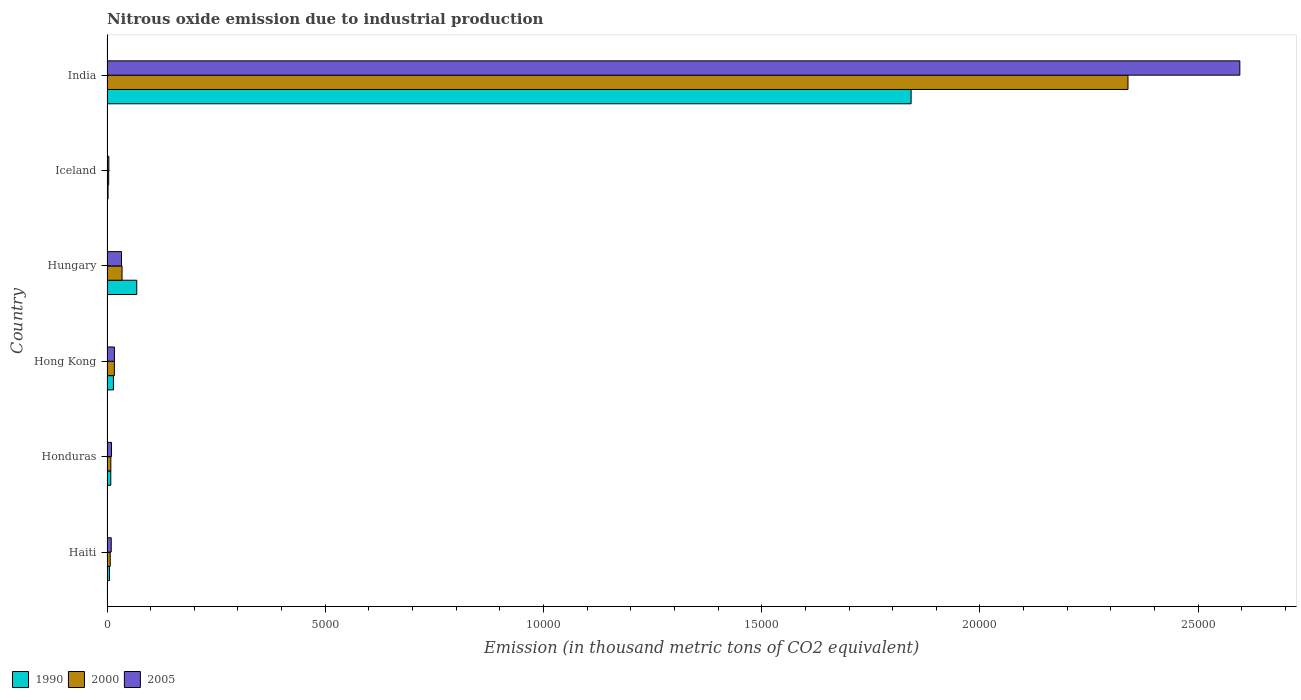How many different coloured bars are there?
Provide a short and direct response. 3. Are the number of bars per tick equal to the number of legend labels?
Make the answer very short. Yes. Are the number of bars on each tick of the Y-axis equal?
Make the answer very short. Yes. How many bars are there on the 5th tick from the top?
Your response must be concise. 3. How many bars are there on the 6th tick from the bottom?
Provide a succinct answer. 3. What is the label of the 4th group of bars from the top?
Your response must be concise. Hong Kong. In how many cases, is the number of bars for a given country not equal to the number of legend labels?
Your answer should be very brief. 0. What is the amount of nitrous oxide emitted in 2000 in India?
Keep it short and to the point. 2.34e+04. Across all countries, what is the maximum amount of nitrous oxide emitted in 2000?
Your answer should be compact. 2.34e+04. Across all countries, what is the minimum amount of nitrous oxide emitted in 2000?
Your response must be concise. 38.6. In which country was the amount of nitrous oxide emitted in 2000 minimum?
Provide a succinct answer. Iceland. What is the total amount of nitrous oxide emitted in 2005 in the graph?
Your answer should be compact. 2.67e+04. What is the difference between the amount of nitrous oxide emitted in 1990 in Honduras and that in India?
Offer a very short reply. -1.83e+04. What is the difference between the amount of nitrous oxide emitted in 2005 in Iceland and the amount of nitrous oxide emitted in 1990 in Hungary?
Offer a terse response. -639.6. What is the average amount of nitrous oxide emitted in 2005 per country?
Ensure brevity in your answer.  4449.87. What is the difference between the amount of nitrous oxide emitted in 2005 and amount of nitrous oxide emitted in 2000 in Hungary?
Offer a terse response. -11.9. In how many countries, is the amount of nitrous oxide emitted in 2005 greater than 3000 thousand metric tons?
Provide a succinct answer. 1. What is the ratio of the amount of nitrous oxide emitted in 2000 in Hungary to that in India?
Provide a short and direct response. 0.01. Is the difference between the amount of nitrous oxide emitted in 2005 in Haiti and Hong Kong greater than the difference between the amount of nitrous oxide emitted in 2000 in Haiti and Hong Kong?
Provide a succinct answer. Yes. What is the difference between the highest and the second highest amount of nitrous oxide emitted in 2005?
Your answer should be compact. 2.56e+04. What is the difference between the highest and the lowest amount of nitrous oxide emitted in 2005?
Offer a terse response. 2.59e+04. Is the sum of the amount of nitrous oxide emitted in 2000 in Haiti and Hungary greater than the maximum amount of nitrous oxide emitted in 1990 across all countries?
Make the answer very short. No. What does the 1st bar from the bottom in Haiti represents?
Give a very brief answer. 1990. How many countries are there in the graph?
Offer a terse response. 6. What is the difference between two consecutive major ticks on the X-axis?
Provide a short and direct response. 5000. Does the graph contain any zero values?
Give a very brief answer. No. Does the graph contain grids?
Give a very brief answer. No. Where does the legend appear in the graph?
Offer a terse response. Bottom left. How many legend labels are there?
Your answer should be compact. 3. How are the legend labels stacked?
Your answer should be very brief. Horizontal. What is the title of the graph?
Your answer should be very brief. Nitrous oxide emission due to industrial production. Does "2004" appear as one of the legend labels in the graph?
Provide a succinct answer. No. What is the label or title of the X-axis?
Provide a short and direct response. Emission (in thousand metric tons of CO2 equivalent). What is the label or title of the Y-axis?
Provide a short and direct response. Country. What is the Emission (in thousand metric tons of CO2 equivalent) in 1990 in Haiti?
Your response must be concise. 56.6. What is the Emission (in thousand metric tons of CO2 equivalent) in 2000 in Haiti?
Offer a terse response. 73.8. What is the Emission (in thousand metric tons of CO2 equivalent) of 2005 in Haiti?
Keep it short and to the point. 97. What is the Emission (in thousand metric tons of CO2 equivalent) of 1990 in Honduras?
Offer a very short reply. 86.6. What is the Emission (in thousand metric tons of CO2 equivalent) of 2000 in Honduras?
Offer a very short reply. 87.5. What is the Emission (in thousand metric tons of CO2 equivalent) in 2005 in Honduras?
Your answer should be compact. 103.3. What is the Emission (in thousand metric tons of CO2 equivalent) of 1990 in Hong Kong?
Your answer should be compact. 147.8. What is the Emission (in thousand metric tons of CO2 equivalent) in 2000 in Hong Kong?
Provide a succinct answer. 168.9. What is the Emission (in thousand metric tons of CO2 equivalent) of 2005 in Hong Kong?
Give a very brief answer. 169.8. What is the Emission (in thousand metric tons of CO2 equivalent) of 1990 in Hungary?
Provide a succinct answer. 681.7. What is the Emission (in thousand metric tons of CO2 equivalent) in 2000 in Hungary?
Provide a succinct answer. 344.5. What is the Emission (in thousand metric tons of CO2 equivalent) in 2005 in Hungary?
Your answer should be compact. 332.6. What is the Emission (in thousand metric tons of CO2 equivalent) of 1990 in Iceland?
Give a very brief answer. 24.6. What is the Emission (in thousand metric tons of CO2 equivalent) in 2000 in Iceland?
Offer a terse response. 38.6. What is the Emission (in thousand metric tons of CO2 equivalent) of 2005 in Iceland?
Ensure brevity in your answer.  42.1. What is the Emission (in thousand metric tons of CO2 equivalent) of 1990 in India?
Make the answer very short. 1.84e+04. What is the Emission (in thousand metric tons of CO2 equivalent) of 2000 in India?
Provide a succinct answer. 2.34e+04. What is the Emission (in thousand metric tons of CO2 equivalent) of 2005 in India?
Your response must be concise. 2.60e+04. Across all countries, what is the maximum Emission (in thousand metric tons of CO2 equivalent) of 1990?
Give a very brief answer. 1.84e+04. Across all countries, what is the maximum Emission (in thousand metric tons of CO2 equivalent) of 2000?
Provide a succinct answer. 2.34e+04. Across all countries, what is the maximum Emission (in thousand metric tons of CO2 equivalent) in 2005?
Give a very brief answer. 2.60e+04. Across all countries, what is the minimum Emission (in thousand metric tons of CO2 equivalent) in 1990?
Your answer should be very brief. 24.6. Across all countries, what is the minimum Emission (in thousand metric tons of CO2 equivalent) in 2000?
Your answer should be compact. 38.6. Across all countries, what is the minimum Emission (in thousand metric tons of CO2 equivalent) in 2005?
Offer a very short reply. 42.1. What is the total Emission (in thousand metric tons of CO2 equivalent) of 1990 in the graph?
Your answer should be compact. 1.94e+04. What is the total Emission (in thousand metric tons of CO2 equivalent) in 2000 in the graph?
Give a very brief answer. 2.41e+04. What is the total Emission (in thousand metric tons of CO2 equivalent) in 2005 in the graph?
Provide a short and direct response. 2.67e+04. What is the difference between the Emission (in thousand metric tons of CO2 equivalent) of 2000 in Haiti and that in Honduras?
Your answer should be compact. -13.7. What is the difference between the Emission (in thousand metric tons of CO2 equivalent) of 2005 in Haiti and that in Honduras?
Your answer should be very brief. -6.3. What is the difference between the Emission (in thousand metric tons of CO2 equivalent) in 1990 in Haiti and that in Hong Kong?
Keep it short and to the point. -91.2. What is the difference between the Emission (in thousand metric tons of CO2 equivalent) in 2000 in Haiti and that in Hong Kong?
Your answer should be very brief. -95.1. What is the difference between the Emission (in thousand metric tons of CO2 equivalent) in 2005 in Haiti and that in Hong Kong?
Your response must be concise. -72.8. What is the difference between the Emission (in thousand metric tons of CO2 equivalent) of 1990 in Haiti and that in Hungary?
Your answer should be very brief. -625.1. What is the difference between the Emission (in thousand metric tons of CO2 equivalent) in 2000 in Haiti and that in Hungary?
Ensure brevity in your answer.  -270.7. What is the difference between the Emission (in thousand metric tons of CO2 equivalent) of 2005 in Haiti and that in Hungary?
Provide a short and direct response. -235.6. What is the difference between the Emission (in thousand metric tons of CO2 equivalent) in 2000 in Haiti and that in Iceland?
Provide a succinct answer. 35.2. What is the difference between the Emission (in thousand metric tons of CO2 equivalent) of 2005 in Haiti and that in Iceland?
Ensure brevity in your answer.  54.9. What is the difference between the Emission (in thousand metric tons of CO2 equivalent) in 1990 in Haiti and that in India?
Your response must be concise. -1.84e+04. What is the difference between the Emission (in thousand metric tons of CO2 equivalent) of 2000 in Haiti and that in India?
Ensure brevity in your answer.  -2.33e+04. What is the difference between the Emission (in thousand metric tons of CO2 equivalent) of 2005 in Haiti and that in India?
Provide a succinct answer. -2.59e+04. What is the difference between the Emission (in thousand metric tons of CO2 equivalent) of 1990 in Honduras and that in Hong Kong?
Ensure brevity in your answer.  -61.2. What is the difference between the Emission (in thousand metric tons of CO2 equivalent) in 2000 in Honduras and that in Hong Kong?
Offer a very short reply. -81.4. What is the difference between the Emission (in thousand metric tons of CO2 equivalent) of 2005 in Honduras and that in Hong Kong?
Offer a very short reply. -66.5. What is the difference between the Emission (in thousand metric tons of CO2 equivalent) of 1990 in Honduras and that in Hungary?
Make the answer very short. -595.1. What is the difference between the Emission (in thousand metric tons of CO2 equivalent) of 2000 in Honduras and that in Hungary?
Provide a succinct answer. -257. What is the difference between the Emission (in thousand metric tons of CO2 equivalent) in 2005 in Honduras and that in Hungary?
Keep it short and to the point. -229.3. What is the difference between the Emission (in thousand metric tons of CO2 equivalent) of 1990 in Honduras and that in Iceland?
Your answer should be compact. 62. What is the difference between the Emission (in thousand metric tons of CO2 equivalent) of 2000 in Honduras and that in Iceland?
Offer a terse response. 48.9. What is the difference between the Emission (in thousand metric tons of CO2 equivalent) in 2005 in Honduras and that in Iceland?
Keep it short and to the point. 61.2. What is the difference between the Emission (in thousand metric tons of CO2 equivalent) of 1990 in Honduras and that in India?
Make the answer very short. -1.83e+04. What is the difference between the Emission (in thousand metric tons of CO2 equivalent) of 2000 in Honduras and that in India?
Ensure brevity in your answer.  -2.33e+04. What is the difference between the Emission (in thousand metric tons of CO2 equivalent) in 2005 in Honduras and that in India?
Your answer should be very brief. -2.59e+04. What is the difference between the Emission (in thousand metric tons of CO2 equivalent) of 1990 in Hong Kong and that in Hungary?
Your answer should be very brief. -533.9. What is the difference between the Emission (in thousand metric tons of CO2 equivalent) in 2000 in Hong Kong and that in Hungary?
Give a very brief answer. -175.6. What is the difference between the Emission (in thousand metric tons of CO2 equivalent) of 2005 in Hong Kong and that in Hungary?
Your answer should be very brief. -162.8. What is the difference between the Emission (in thousand metric tons of CO2 equivalent) in 1990 in Hong Kong and that in Iceland?
Provide a short and direct response. 123.2. What is the difference between the Emission (in thousand metric tons of CO2 equivalent) of 2000 in Hong Kong and that in Iceland?
Provide a short and direct response. 130.3. What is the difference between the Emission (in thousand metric tons of CO2 equivalent) of 2005 in Hong Kong and that in Iceland?
Ensure brevity in your answer.  127.7. What is the difference between the Emission (in thousand metric tons of CO2 equivalent) of 1990 in Hong Kong and that in India?
Provide a succinct answer. -1.83e+04. What is the difference between the Emission (in thousand metric tons of CO2 equivalent) of 2000 in Hong Kong and that in India?
Your answer should be very brief. -2.32e+04. What is the difference between the Emission (in thousand metric tons of CO2 equivalent) in 2005 in Hong Kong and that in India?
Provide a short and direct response. -2.58e+04. What is the difference between the Emission (in thousand metric tons of CO2 equivalent) in 1990 in Hungary and that in Iceland?
Give a very brief answer. 657.1. What is the difference between the Emission (in thousand metric tons of CO2 equivalent) of 2000 in Hungary and that in Iceland?
Make the answer very short. 305.9. What is the difference between the Emission (in thousand metric tons of CO2 equivalent) in 2005 in Hungary and that in Iceland?
Your answer should be very brief. 290.5. What is the difference between the Emission (in thousand metric tons of CO2 equivalent) of 1990 in Hungary and that in India?
Offer a very short reply. -1.77e+04. What is the difference between the Emission (in thousand metric tons of CO2 equivalent) in 2000 in Hungary and that in India?
Provide a short and direct response. -2.30e+04. What is the difference between the Emission (in thousand metric tons of CO2 equivalent) in 2005 in Hungary and that in India?
Give a very brief answer. -2.56e+04. What is the difference between the Emission (in thousand metric tons of CO2 equivalent) of 1990 in Iceland and that in India?
Give a very brief answer. -1.84e+04. What is the difference between the Emission (in thousand metric tons of CO2 equivalent) of 2000 in Iceland and that in India?
Your response must be concise. -2.34e+04. What is the difference between the Emission (in thousand metric tons of CO2 equivalent) in 2005 in Iceland and that in India?
Ensure brevity in your answer.  -2.59e+04. What is the difference between the Emission (in thousand metric tons of CO2 equivalent) in 1990 in Haiti and the Emission (in thousand metric tons of CO2 equivalent) in 2000 in Honduras?
Your answer should be very brief. -30.9. What is the difference between the Emission (in thousand metric tons of CO2 equivalent) in 1990 in Haiti and the Emission (in thousand metric tons of CO2 equivalent) in 2005 in Honduras?
Make the answer very short. -46.7. What is the difference between the Emission (in thousand metric tons of CO2 equivalent) of 2000 in Haiti and the Emission (in thousand metric tons of CO2 equivalent) of 2005 in Honduras?
Your answer should be very brief. -29.5. What is the difference between the Emission (in thousand metric tons of CO2 equivalent) in 1990 in Haiti and the Emission (in thousand metric tons of CO2 equivalent) in 2000 in Hong Kong?
Keep it short and to the point. -112.3. What is the difference between the Emission (in thousand metric tons of CO2 equivalent) of 1990 in Haiti and the Emission (in thousand metric tons of CO2 equivalent) of 2005 in Hong Kong?
Make the answer very short. -113.2. What is the difference between the Emission (in thousand metric tons of CO2 equivalent) of 2000 in Haiti and the Emission (in thousand metric tons of CO2 equivalent) of 2005 in Hong Kong?
Keep it short and to the point. -96. What is the difference between the Emission (in thousand metric tons of CO2 equivalent) of 1990 in Haiti and the Emission (in thousand metric tons of CO2 equivalent) of 2000 in Hungary?
Provide a short and direct response. -287.9. What is the difference between the Emission (in thousand metric tons of CO2 equivalent) in 1990 in Haiti and the Emission (in thousand metric tons of CO2 equivalent) in 2005 in Hungary?
Make the answer very short. -276. What is the difference between the Emission (in thousand metric tons of CO2 equivalent) in 2000 in Haiti and the Emission (in thousand metric tons of CO2 equivalent) in 2005 in Hungary?
Provide a succinct answer. -258.8. What is the difference between the Emission (in thousand metric tons of CO2 equivalent) in 2000 in Haiti and the Emission (in thousand metric tons of CO2 equivalent) in 2005 in Iceland?
Your response must be concise. 31.7. What is the difference between the Emission (in thousand metric tons of CO2 equivalent) of 1990 in Haiti and the Emission (in thousand metric tons of CO2 equivalent) of 2000 in India?
Provide a short and direct response. -2.33e+04. What is the difference between the Emission (in thousand metric tons of CO2 equivalent) in 1990 in Haiti and the Emission (in thousand metric tons of CO2 equivalent) in 2005 in India?
Offer a terse response. -2.59e+04. What is the difference between the Emission (in thousand metric tons of CO2 equivalent) in 2000 in Haiti and the Emission (in thousand metric tons of CO2 equivalent) in 2005 in India?
Your response must be concise. -2.59e+04. What is the difference between the Emission (in thousand metric tons of CO2 equivalent) of 1990 in Honduras and the Emission (in thousand metric tons of CO2 equivalent) of 2000 in Hong Kong?
Keep it short and to the point. -82.3. What is the difference between the Emission (in thousand metric tons of CO2 equivalent) in 1990 in Honduras and the Emission (in thousand metric tons of CO2 equivalent) in 2005 in Hong Kong?
Make the answer very short. -83.2. What is the difference between the Emission (in thousand metric tons of CO2 equivalent) in 2000 in Honduras and the Emission (in thousand metric tons of CO2 equivalent) in 2005 in Hong Kong?
Your response must be concise. -82.3. What is the difference between the Emission (in thousand metric tons of CO2 equivalent) of 1990 in Honduras and the Emission (in thousand metric tons of CO2 equivalent) of 2000 in Hungary?
Provide a short and direct response. -257.9. What is the difference between the Emission (in thousand metric tons of CO2 equivalent) of 1990 in Honduras and the Emission (in thousand metric tons of CO2 equivalent) of 2005 in Hungary?
Provide a short and direct response. -246. What is the difference between the Emission (in thousand metric tons of CO2 equivalent) in 2000 in Honduras and the Emission (in thousand metric tons of CO2 equivalent) in 2005 in Hungary?
Provide a succinct answer. -245.1. What is the difference between the Emission (in thousand metric tons of CO2 equivalent) of 1990 in Honduras and the Emission (in thousand metric tons of CO2 equivalent) of 2000 in Iceland?
Provide a short and direct response. 48. What is the difference between the Emission (in thousand metric tons of CO2 equivalent) of 1990 in Honduras and the Emission (in thousand metric tons of CO2 equivalent) of 2005 in Iceland?
Provide a short and direct response. 44.5. What is the difference between the Emission (in thousand metric tons of CO2 equivalent) of 2000 in Honduras and the Emission (in thousand metric tons of CO2 equivalent) of 2005 in Iceland?
Give a very brief answer. 45.4. What is the difference between the Emission (in thousand metric tons of CO2 equivalent) of 1990 in Honduras and the Emission (in thousand metric tons of CO2 equivalent) of 2000 in India?
Offer a very short reply. -2.33e+04. What is the difference between the Emission (in thousand metric tons of CO2 equivalent) of 1990 in Honduras and the Emission (in thousand metric tons of CO2 equivalent) of 2005 in India?
Provide a short and direct response. -2.59e+04. What is the difference between the Emission (in thousand metric tons of CO2 equivalent) of 2000 in Honduras and the Emission (in thousand metric tons of CO2 equivalent) of 2005 in India?
Your answer should be very brief. -2.59e+04. What is the difference between the Emission (in thousand metric tons of CO2 equivalent) in 1990 in Hong Kong and the Emission (in thousand metric tons of CO2 equivalent) in 2000 in Hungary?
Offer a very short reply. -196.7. What is the difference between the Emission (in thousand metric tons of CO2 equivalent) in 1990 in Hong Kong and the Emission (in thousand metric tons of CO2 equivalent) in 2005 in Hungary?
Your answer should be very brief. -184.8. What is the difference between the Emission (in thousand metric tons of CO2 equivalent) in 2000 in Hong Kong and the Emission (in thousand metric tons of CO2 equivalent) in 2005 in Hungary?
Keep it short and to the point. -163.7. What is the difference between the Emission (in thousand metric tons of CO2 equivalent) of 1990 in Hong Kong and the Emission (in thousand metric tons of CO2 equivalent) of 2000 in Iceland?
Provide a short and direct response. 109.2. What is the difference between the Emission (in thousand metric tons of CO2 equivalent) of 1990 in Hong Kong and the Emission (in thousand metric tons of CO2 equivalent) of 2005 in Iceland?
Your answer should be compact. 105.7. What is the difference between the Emission (in thousand metric tons of CO2 equivalent) in 2000 in Hong Kong and the Emission (in thousand metric tons of CO2 equivalent) in 2005 in Iceland?
Keep it short and to the point. 126.8. What is the difference between the Emission (in thousand metric tons of CO2 equivalent) in 1990 in Hong Kong and the Emission (in thousand metric tons of CO2 equivalent) in 2000 in India?
Your answer should be very brief. -2.32e+04. What is the difference between the Emission (in thousand metric tons of CO2 equivalent) of 1990 in Hong Kong and the Emission (in thousand metric tons of CO2 equivalent) of 2005 in India?
Your response must be concise. -2.58e+04. What is the difference between the Emission (in thousand metric tons of CO2 equivalent) of 2000 in Hong Kong and the Emission (in thousand metric tons of CO2 equivalent) of 2005 in India?
Your answer should be very brief. -2.58e+04. What is the difference between the Emission (in thousand metric tons of CO2 equivalent) in 1990 in Hungary and the Emission (in thousand metric tons of CO2 equivalent) in 2000 in Iceland?
Your answer should be compact. 643.1. What is the difference between the Emission (in thousand metric tons of CO2 equivalent) of 1990 in Hungary and the Emission (in thousand metric tons of CO2 equivalent) of 2005 in Iceland?
Your answer should be compact. 639.6. What is the difference between the Emission (in thousand metric tons of CO2 equivalent) of 2000 in Hungary and the Emission (in thousand metric tons of CO2 equivalent) of 2005 in Iceland?
Give a very brief answer. 302.4. What is the difference between the Emission (in thousand metric tons of CO2 equivalent) in 1990 in Hungary and the Emission (in thousand metric tons of CO2 equivalent) in 2000 in India?
Offer a very short reply. -2.27e+04. What is the difference between the Emission (in thousand metric tons of CO2 equivalent) in 1990 in Hungary and the Emission (in thousand metric tons of CO2 equivalent) in 2005 in India?
Provide a short and direct response. -2.53e+04. What is the difference between the Emission (in thousand metric tons of CO2 equivalent) in 2000 in Hungary and the Emission (in thousand metric tons of CO2 equivalent) in 2005 in India?
Provide a short and direct response. -2.56e+04. What is the difference between the Emission (in thousand metric tons of CO2 equivalent) in 1990 in Iceland and the Emission (in thousand metric tons of CO2 equivalent) in 2000 in India?
Your answer should be compact. -2.34e+04. What is the difference between the Emission (in thousand metric tons of CO2 equivalent) of 1990 in Iceland and the Emission (in thousand metric tons of CO2 equivalent) of 2005 in India?
Make the answer very short. -2.59e+04. What is the difference between the Emission (in thousand metric tons of CO2 equivalent) in 2000 in Iceland and the Emission (in thousand metric tons of CO2 equivalent) in 2005 in India?
Offer a very short reply. -2.59e+04. What is the average Emission (in thousand metric tons of CO2 equivalent) in 1990 per country?
Provide a short and direct response. 3236.68. What is the average Emission (in thousand metric tons of CO2 equivalent) of 2000 per country?
Offer a terse response. 4017.43. What is the average Emission (in thousand metric tons of CO2 equivalent) of 2005 per country?
Keep it short and to the point. 4449.87. What is the difference between the Emission (in thousand metric tons of CO2 equivalent) of 1990 and Emission (in thousand metric tons of CO2 equivalent) of 2000 in Haiti?
Give a very brief answer. -17.2. What is the difference between the Emission (in thousand metric tons of CO2 equivalent) of 1990 and Emission (in thousand metric tons of CO2 equivalent) of 2005 in Haiti?
Your response must be concise. -40.4. What is the difference between the Emission (in thousand metric tons of CO2 equivalent) of 2000 and Emission (in thousand metric tons of CO2 equivalent) of 2005 in Haiti?
Your answer should be very brief. -23.2. What is the difference between the Emission (in thousand metric tons of CO2 equivalent) of 1990 and Emission (in thousand metric tons of CO2 equivalent) of 2000 in Honduras?
Make the answer very short. -0.9. What is the difference between the Emission (in thousand metric tons of CO2 equivalent) in 1990 and Emission (in thousand metric tons of CO2 equivalent) in 2005 in Honduras?
Offer a terse response. -16.7. What is the difference between the Emission (in thousand metric tons of CO2 equivalent) in 2000 and Emission (in thousand metric tons of CO2 equivalent) in 2005 in Honduras?
Provide a succinct answer. -15.8. What is the difference between the Emission (in thousand metric tons of CO2 equivalent) of 1990 and Emission (in thousand metric tons of CO2 equivalent) of 2000 in Hong Kong?
Your answer should be very brief. -21.1. What is the difference between the Emission (in thousand metric tons of CO2 equivalent) of 1990 and Emission (in thousand metric tons of CO2 equivalent) of 2000 in Hungary?
Offer a terse response. 337.2. What is the difference between the Emission (in thousand metric tons of CO2 equivalent) of 1990 and Emission (in thousand metric tons of CO2 equivalent) of 2005 in Hungary?
Offer a terse response. 349.1. What is the difference between the Emission (in thousand metric tons of CO2 equivalent) of 2000 and Emission (in thousand metric tons of CO2 equivalent) of 2005 in Hungary?
Ensure brevity in your answer.  11.9. What is the difference between the Emission (in thousand metric tons of CO2 equivalent) of 1990 and Emission (in thousand metric tons of CO2 equivalent) of 2005 in Iceland?
Keep it short and to the point. -17.5. What is the difference between the Emission (in thousand metric tons of CO2 equivalent) of 1990 and Emission (in thousand metric tons of CO2 equivalent) of 2000 in India?
Offer a terse response. -4968.5. What is the difference between the Emission (in thousand metric tons of CO2 equivalent) of 1990 and Emission (in thousand metric tons of CO2 equivalent) of 2005 in India?
Provide a short and direct response. -7531.6. What is the difference between the Emission (in thousand metric tons of CO2 equivalent) in 2000 and Emission (in thousand metric tons of CO2 equivalent) in 2005 in India?
Keep it short and to the point. -2563.1. What is the ratio of the Emission (in thousand metric tons of CO2 equivalent) in 1990 in Haiti to that in Honduras?
Offer a terse response. 0.65. What is the ratio of the Emission (in thousand metric tons of CO2 equivalent) in 2000 in Haiti to that in Honduras?
Offer a very short reply. 0.84. What is the ratio of the Emission (in thousand metric tons of CO2 equivalent) of 2005 in Haiti to that in Honduras?
Provide a succinct answer. 0.94. What is the ratio of the Emission (in thousand metric tons of CO2 equivalent) in 1990 in Haiti to that in Hong Kong?
Offer a terse response. 0.38. What is the ratio of the Emission (in thousand metric tons of CO2 equivalent) of 2000 in Haiti to that in Hong Kong?
Your response must be concise. 0.44. What is the ratio of the Emission (in thousand metric tons of CO2 equivalent) in 2005 in Haiti to that in Hong Kong?
Keep it short and to the point. 0.57. What is the ratio of the Emission (in thousand metric tons of CO2 equivalent) in 1990 in Haiti to that in Hungary?
Give a very brief answer. 0.08. What is the ratio of the Emission (in thousand metric tons of CO2 equivalent) of 2000 in Haiti to that in Hungary?
Keep it short and to the point. 0.21. What is the ratio of the Emission (in thousand metric tons of CO2 equivalent) in 2005 in Haiti to that in Hungary?
Provide a short and direct response. 0.29. What is the ratio of the Emission (in thousand metric tons of CO2 equivalent) in 1990 in Haiti to that in Iceland?
Your answer should be very brief. 2.3. What is the ratio of the Emission (in thousand metric tons of CO2 equivalent) of 2000 in Haiti to that in Iceland?
Provide a succinct answer. 1.91. What is the ratio of the Emission (in thousand metric tons of CO2 equivalent) in 2005 in Haiti to that in Iceland?
Your answer should be compact. 2.3. What is the ratio of the Emission (in thousand metric tons of CO2 equivalent) of 1990 in Haiti to that in India?
Ensure brevity in your answer.  0. What is the ratio of the Emission (in thousand metric tons of CO2 equivalent) of 2000 in Haiti to that in India?
Your answer should be very brief. 0. What is the ratio of the Emission (in thousand metric tons of CO2 equivalent) in 2005 in Haiti to that in India?
Your answer should be very brief. 0. What is the ratio of the Emission (in thousand metric tons of CO2 equivalent) in 1990 in Honduras to that in Hong Kong?
Give a very brief answer. 0.59. What is the ratio of the Emission (in thousand metric tons of CO2 equivalent) in 2000 in Honduras to that in Hong Kong?
Offer a very short reply. 0.52. What is the ratio of the Emission (in thousand metric tons of CO2 equivalent) of 2005 in Honduras to that in Hong Kong?
Your answer should be very brief. 0.61. What is the ratio of the Emission (in thousand metric tons of CO2 equivalent) of 1990 in Honduras to that in Hungary?
Provide a succinct answer. 0.13. What is the ratio of the Emission (in thousand metric tons of CO2 equivalent) of 2000 in Honduras to that in Hungary?
Offer a terse response. 0.25. What is the ratio of the Emission (in thousand metric tons of CO2 equivalent) of 2005 in Honduras to that in Hungary?
Your answer should be compact. 0.31. What is the ratio of the Emission (in thousand metric tons of CO2 equivalent) in 1990 in Honduras to that in Iceland?
Give a very brief answer. 3.52. What is the ratio of the Emission (in thousand metric tons of CO2 equivalent) in 2000 in Honduras to that in Iceland?
Your answer should be very brief. 2.27. What is the ratio of the Emission (in thousand metric tons of CO2 equivalent) of 2005 in Honduras to that in Iceland?
Ensure brevity in your answer.  2.45. What is the ratio of the Emission (in thousand metric tons of CO2 equivalent) in 1990 in Honduras to that in India?
Your response must be concise. 0. What is the ratio of the Emission (in thousand metric tons of CO2 equivalent) of 2000 in Honduras to that in India?
Provide a succinct answer. 0. What is the ratio of the Emission (in thousand metric tons of CO2 equivalent) of 2005 in Honduras to that in India?
Your answer should be very brief. 0. What is the ratio of the Emission (in thousand metric tons of CO2 equivalent) of 1990 in Hong Kong to that in Hungary?
Offer a terse response. 0.22. What is the ratio of the Emission (in thousand metric tons of CO2 equivalent) of 2000 in Hong Kong to that in Hungary?
Make the answer very short. 0.49. What is the ratio of the Emission (in thousand metric tons of CO2 equivalent) in 2005 in Hong Kong to that in Hungary?
Provide a short and direct response. 0.51. What is the ratio of the Emission (in thousand metric tons of CO2 equivalent) in 1990 in Hong Kong to that in Iceland?
Provide a succinct answer. 6.01. What is the ratio of the Emission (in thousand metric tons of CO2 equivalent) of 2000 in Hong Kong to that in Iceland?
Provide a succinct answer. 4.38. What is the ratio of the Emission (in thousand metric tons of CO2 equivalent) of 2005 in Hong Kong to that in Iceland?
Keep it short and to the point. 4.03. What is the ratio of the Emission (in thousand metric tons of CO2 equivalent) of 1990 in Hong Kong to that in India?
Provide a short and direct response. 0.01. What is the ratio of the Emission (in thousand metric tons of CO2 equivalent) in 2000 in Hong Kong to that in India?
Make the answer very short. 0.01. What is the ratio of the Emission (in thousand metric tons of CO2 equivalent) of 2005 in Hong Kong to that in India?
Ensure brevity in your answer.  0.01. What is the ratio of the Emission (in thousand metric tons of CO2 equivalent) in 1990 in Hungary to that in Iceland?
Ensure brevity in your answer.  27.71. What is the ratio of the Emission (in thousand metric tons of CO2 equivalent) of 2000 in Hungary to that in Iceland?
Keep it short and to the point. 8.92. What is the ratio of the Emission (in thousand metric tons of CO2 equivalent) of 2005 in Hungary to that in Iceland?
Ensure brevity in your answer.  7.9. What is the ratio of the Emission (in thousand metric tons of CO2 equivalent) of 1990 in Hungary to that in India?
Keep it short and to the point. 0.04. What is the ratio of the Emission (in thousand metric tons of CO2 equivalent) in 2000 in Hungary to that in India?
Ensure brevity in your answer.  0.01. What is the ratio of the Emission (in thousand metric tons of CO2 equivalent) of 2005 in Hungary to that in India?
Give a very brief answer. 0.01. What is the ratio of the Emission (in thousand metric tons of CO2 equivalent) of 1990 in Iceland to that in India?
Offer a very short reply. 0. What is the ratio of the Emission (in thousand metric tons of CO2 equivalent) of 2000 in Iceland to that in India?
Keep it short and to the point. 0. What is the ratio of the Emission (in thousand metric tons of CO2 equivalent) in 2005 in Iceland to that in India?
Offer a very short reply. 0. What is the difference between the highest and the second highest Emission (in thousand metric tons of CO2 equivalent) of 1990?
Your answer should be very brief. 1.77e+04. What is the difference between the highest and the second highest Emission (in thousand metric tons of CO2 equivalent) of 2000?
Your answer should be compact. 2.30e+04. What is the difference between the highest and the second highest Emission (in thousand metric tons of CO2 equivalent) of 2005?
Make the answer very short. 2.56e+04. What is the difference between the highest and the lowest Emission (in thousand metric tons of CO2 equivalent) in 1990?
Provide a short and direct response. 1.84e+04. What is the difference between the highest and the lowest Emission (in thousand metric tons of CO2 equivalent) in 2000?
Your answer should be very brief. 2.34e+04. What is the difference between the highest and the lowest Emission (in thousand metric tons of CO2 equivalent) in 2005?
Offer a terse response. 2.59e+04. 